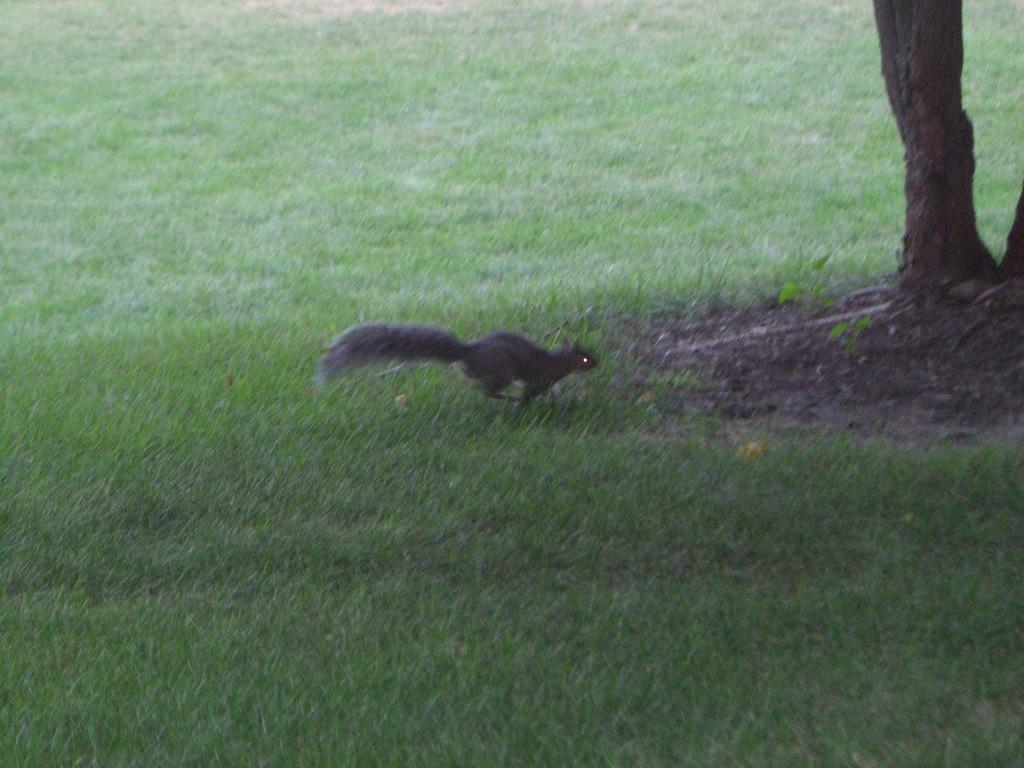What type of animal is in the image? There is a black squirrel in the image. What is the squirrel doing in the image? The squirrel is running on the grass. What is in front of the squirrel in the image? There is a tree trunk in front of the squirrel. What sense is the squirrel using to watch the limit in the image? There is no mention of the squirrel watching a limit in the image, and squirrels do not have the ability to watch limits. 